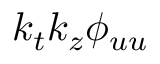<formula> <loc_0><loc_0><loc_500><loc_500>k _ { t } k _ { z } \phi _ { u u }</formula> 